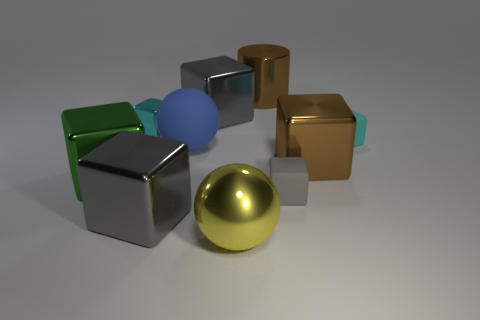There is a cyan thing that is left of the big yellow ball; is its shape the same as the big gray object that is in front of the green block?
Your answer should be very brief. Yes. What number of other things are the same size as the cyan shiny cube?
Your answer should be very brief. 2. How big is the yellow shiny object?
Offer a very short reply. Large. Are the large gray block that is in front of the small gray matte thing and the big blue ball made of the same material?
Offer a very short reply. No. The other big object that is the same shape as the blue object is what color?
Your response must be concise. Yellow. There is a matte cube behind the green metallic thing; does it have the same color as the tiny shiny block?
Make the answer very short. Yes. Are there any gray cubes in front of the brown metal cube?
Provide a short and direct response. Yes. There is a cube that is both behind the tiny cyan matte cube and left of the blue object; what color is it?
Provide a succinct answer. Cyan. There is another thing that is the same color as the tiny shiny object; what shape is it?
Your response must be concise. Cube. There is a gray metallic thing that is behind the rubber thing to the left of the big yellow thing; what size is it?
Your answer should be compact. Large. 